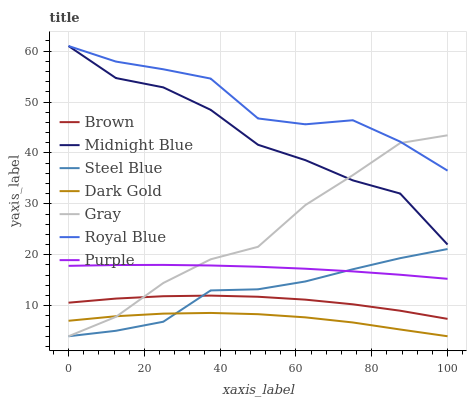Does Dark Gold have the minimum area under the curve?
Answer yes or no. Yes. Does Royal Blue have the maximum area under the curve?
Answer yes or no. Yes. Does Midnight Blue have the minimum area under the curve?
Answer yes or no. No. Does Midnight Blue have the maximum area under the curve?
Answer yes or no. No. Is Purple the smoothest?
Answer yes or no. Yes. Is Midnight Blue the roughest?
Answer yes or no. Yes. Is Gray the smoothest?
Answer yes or no. No. Is Gray the roughest?
Answer yes or no. No. Does Gray have the lowest value?
Answer yes or no. Yes. Does Midnight Blue have the lowest value?
Answer yes or no. No. Does Royal Blue have the highest value?
Answer yes or no. Yes. Does Gray have the highest value?
Answer yes or no. No. Is Brown less than Royal Blue?
Answer yes or no. Yes. Is Royal Blue greater than Purple?
Answer yes or no. Yes. Does Gray intersect Brown?
Answer yes or no. Yes. Is Gray less than Brown?
Answer yes or no. No. Is Gray greater than Brown?
Answer yes or no. No. Does Brown intersect Royal Blue?
Answer yes or no. No. 